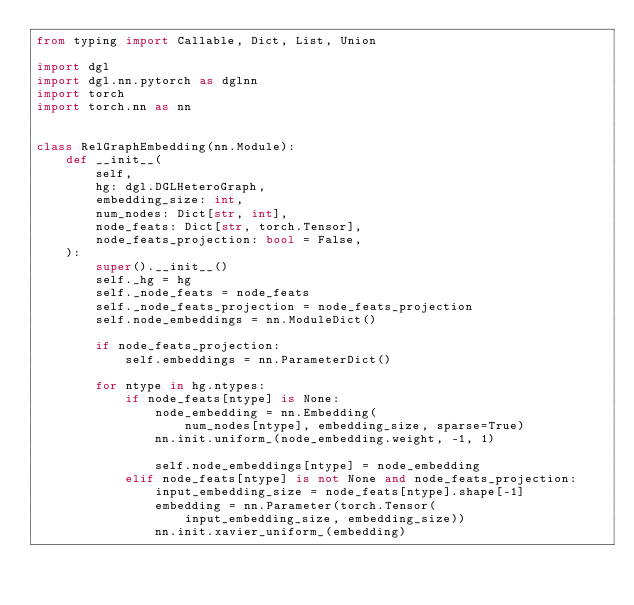<code> <loc_0><loc_0><loc_500><loc_500><_Python_>from typing import Callable, Dict, List, Union

import dgl
import dgl.nn.pytorch as dglnn
import torch
import torch.nn as nn


class RelGraphEmbedding(nn.Module):
    def __init__(
        self,
        hg: dgl.DGLHeteroGraph,
        embedding_size: int,
        num_nodes: Dict[str, int],
        node_feats: Dict[str, torch.Tensor],
        node_feats_projection: bool = False,
    ):
        super().__init__()
        self._hg = hg
        self._node_feats = node_feats
        self._node_feats_projection = node_feats_projection
        self.node_embeddings = nn.ModuleDict()

        if node_feats_projection:
            self.embeddings = nn.ParameterDict()

        for ntype in hg.ntypes:
            if node_feats[ntype] is None:
                node_embedding = nn.Embedding(
                    num_nodes[ntype], embedding_size, sparse=True)
                nn.init.uniform_(node_embedding.weight, -1, 1)

                self.node_embeddings[ntype] = node_embedding
            elif node_feats[ntype] is not None and node_feats_projection:
                input_embedding_size = node_feats[ntype].shape[-1]
                embedding = nn.Parameter(torch.Tensor(
                    input_embedding_size, embedding_size))
                nn.init.xavier_uniform_(embedding)
</code> 